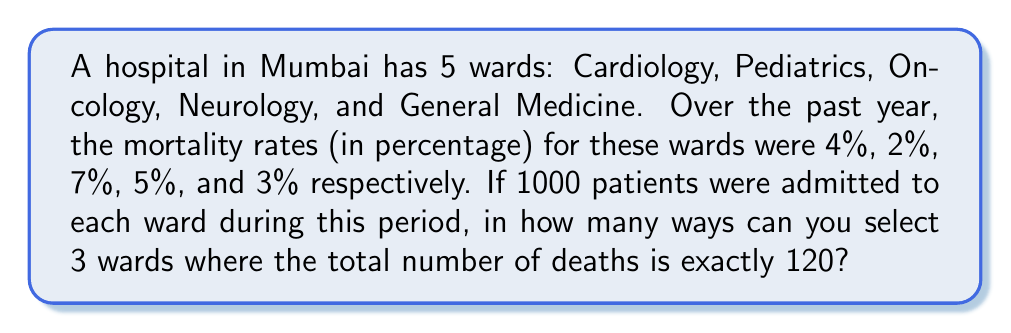Give your solution to this math problem. Let's approach this step-by-step:

1) First, let's calculate the number of deaths in each ward:
   Cardiology: $1000 \times 4\% = 40$ deaths
   Pediatrics: $1000 \times 2\% = 20$ deaths
   Oncology: $1000 \times 7\% = 70$ deaths
   Neurology: $1000 \times 5\% = 50$ deaths
   General Medicine: $1000 \times 3\% = 30$ deaths

2) Now, we need to find combinations of 3 wards where the sum of deaths is exactly 120.

3) Let's list all possible combinations:
   Cardiology + Oncology + Neurology: $40 + 70 + 50 = 160$
   Cardiology + Oncology + General Medicine: $40 + 70 + 30 = 140$
   Cardiology + Pediatrics + Oncology: $40 + 20 + 70 = 130$
   Oncology + Neurology + General Medicine: $70 + 50 + 30 = 150$
   Cardiology + Pediatrics + Neurology: $40 + 20 + 50 = 110$
   Cardiology + Pediatrics + General Medicine: $40 + 20 + 30 = 90$
   Pediatrics + Oncology + Neurology: $20 + 70 + 50 = 140$
   Pediatrics + Oncology + General Medicine: $20 + 70 + 30 = 120$
   Pediatrics + Neurology + General Medicine: $20 + 50 + 30 = 100$

4) From this list, we can see that only one combination results in exactly 120 deaths:
   Pediatrics + Oncology + General Medicine

5) Therefore, there is only one way to select 3 wards where the total number of deaths is exactly 120.
Answer: 1 